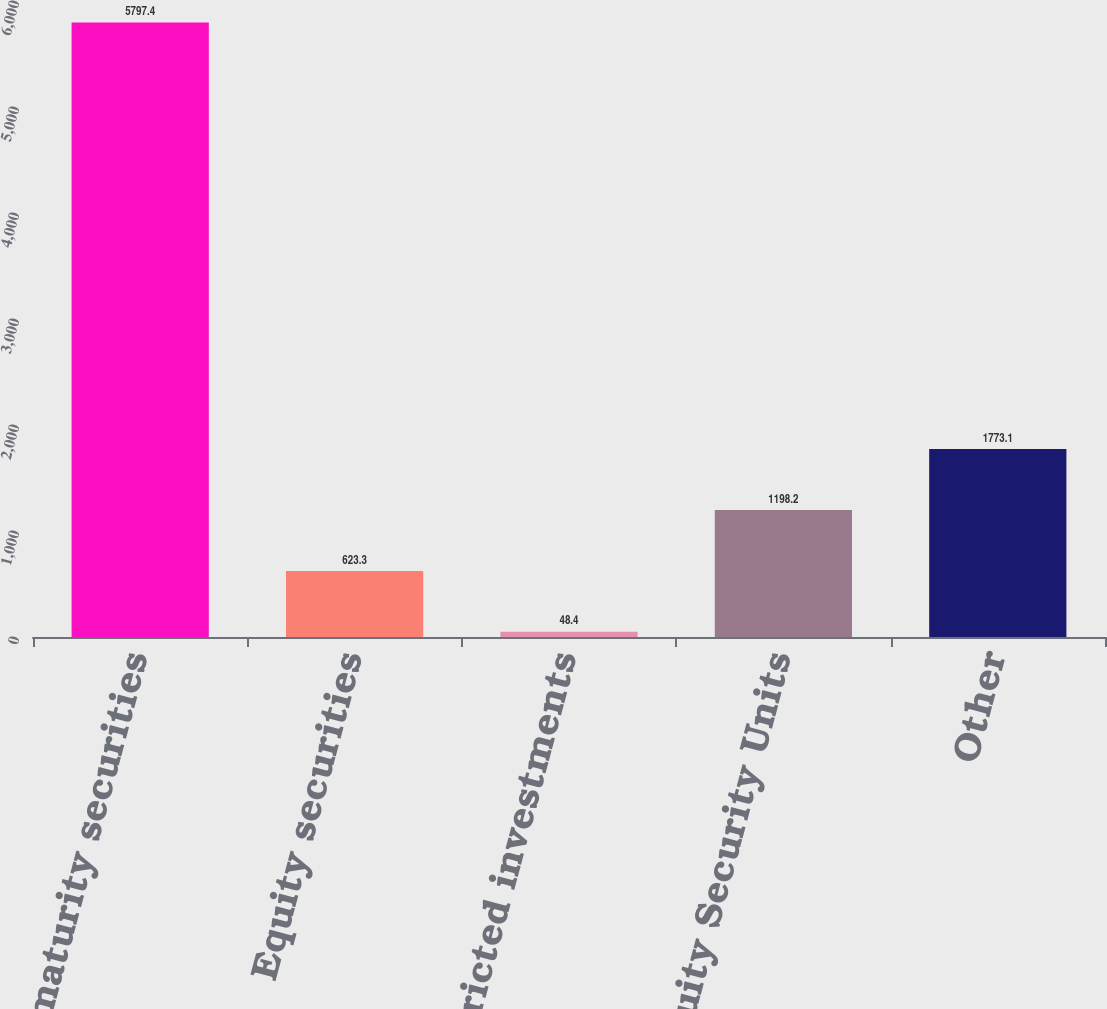<chart> <loc_0><loc_0><loc_500><loc_500><bar_chart><fcel>Fixed maturity securities<fcel>Equity securities<fcel>Restricted investments<fcel>Equity Security Units<fcel>Other<nl><fcel>5797.4<fcel>623.3<fcel>48.4<fcel>1198.2<fcel>1773.1<nl></chart> 